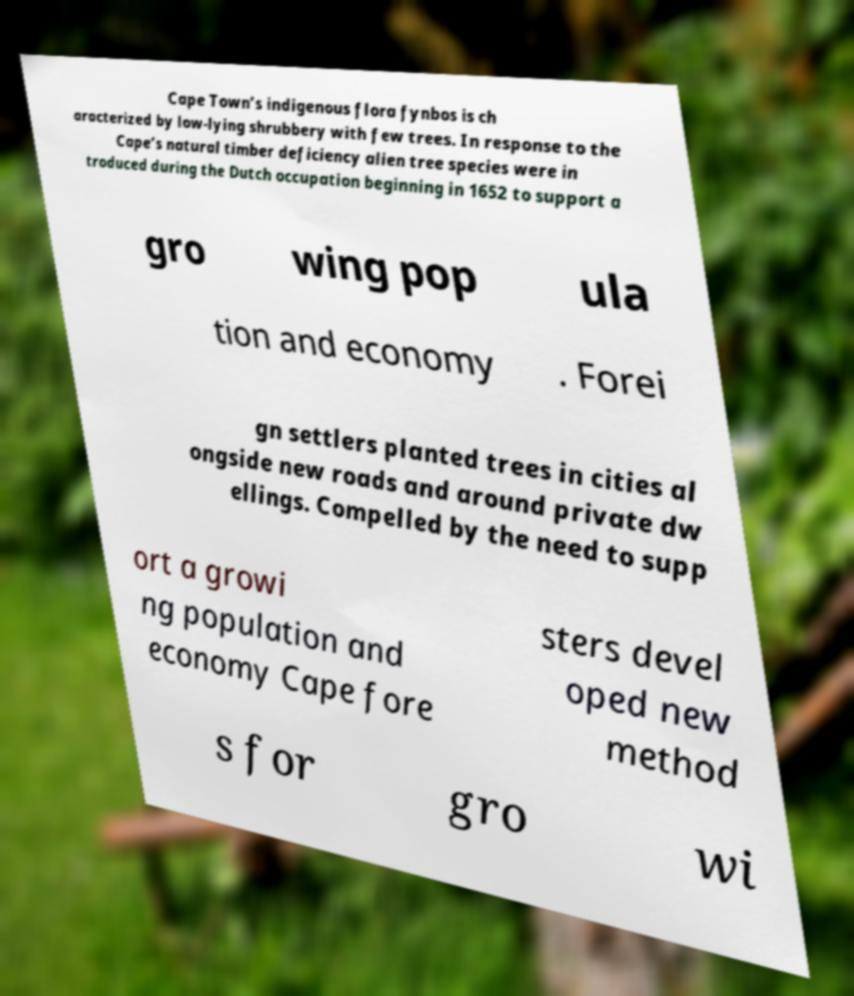Can you read and provide the text displayed in the image?This photo seems to have some interesting text. Can you extract and type it out for me? Cape Town’s indigenous flora fynbos is ch aracterized by low-lying shrubbery with few trees. In response to the Cape’s natural timber deficiency alien tree species were in troduced during the Dutch occupation beginning in 1652 to support a gro wing pop ula tion and economy . Forei gn settlers planted trees in cities al ongside new roads and around private dw ellings. Compelled by the need to supp ort a growi ng population and economy Cape fore sters devel oped new method s for gro wi 